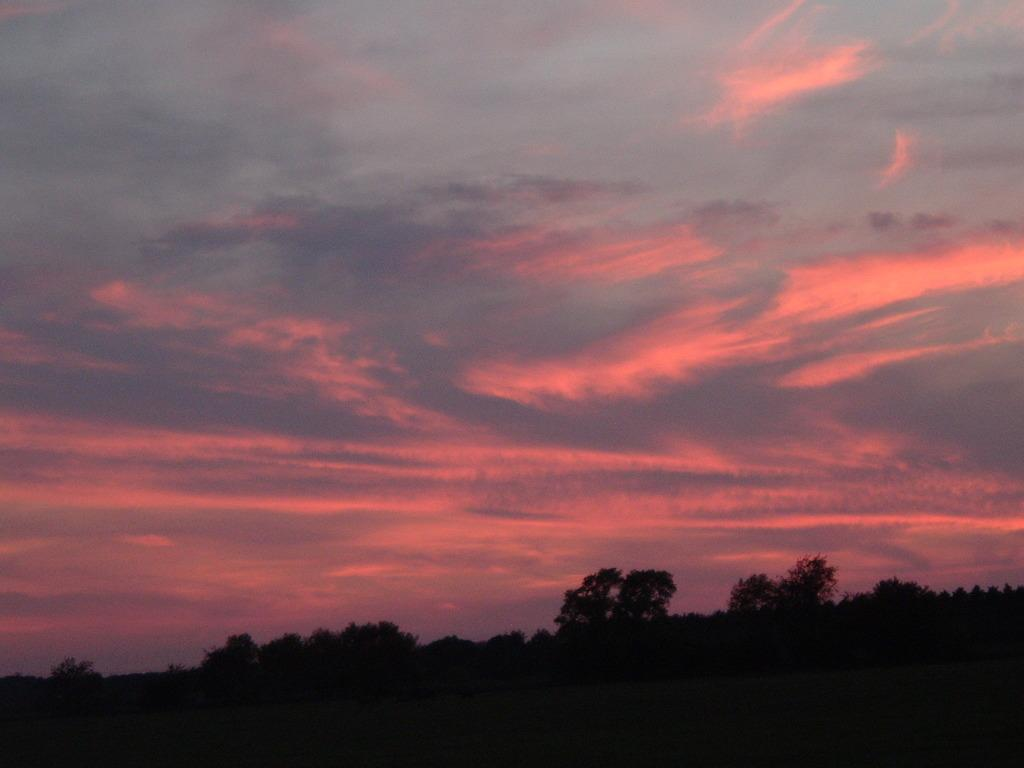What type of vegetation is visible at the bottom side of the image? There are trees at the bottom side of the image. What natural element is visible at the top side of the image? There is sky at the top side of the image. Where is the glove located in the image? There is no glove present in the image. What type of alarm can be heard in the image? There is no sound or alarm present in the image, as it is a still image. 